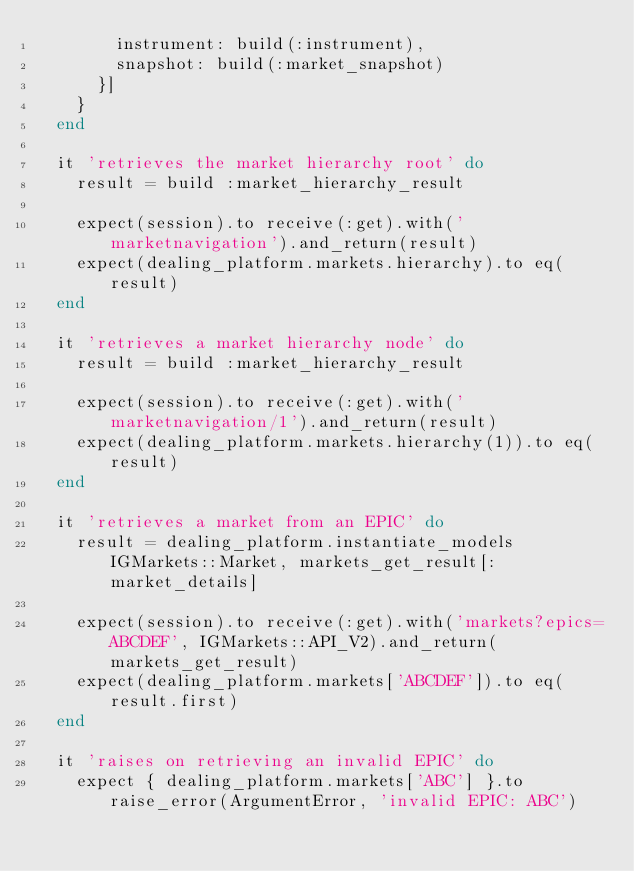<code> <loc_0><loc_0><loc_500><loc_500><_Ruby_>        instrument: build(:instrument),
        snapshot: build(:market_snapshot)
      }]
    }
  end

  it 'retrieves the market hierarchy root' do
    result = build :market_hierarchy_result

    expect(session).to receive(:get).with('marketnavigation').and_return(result)
    expect(dealing_platform.markets.hierarchy).to eq(result)
  end

  it 'retrieves a market hierarchy node' do
    result = build :market_hierarchy_result

    expect(session).to receive(:get).with('marketnavigation/1').and_return(result)
    expect(dealing_platform.markets.hierarchy(1)).to eq(result)
  end

  it 'retrieves a market from an EPIC' do
    result = dealing_platform.instantiate_models IGMarkets::Market, markets_get_result[:market_details]

    expect(session).to receive(:get).with('markets?epics=ABCDEF', IGMarkets::API_V2).and_return(markets_get_result)
    expect(dealing_platform.markets['ABCDEF']).to eq(result.first)
  end

  it 'raises on retrieving an invalid EPIC' do
    expect { dealing_platform.markets['ABC'] }.to raise_error(ArgumentError, 'invalid EPIC: ABC')</code> 